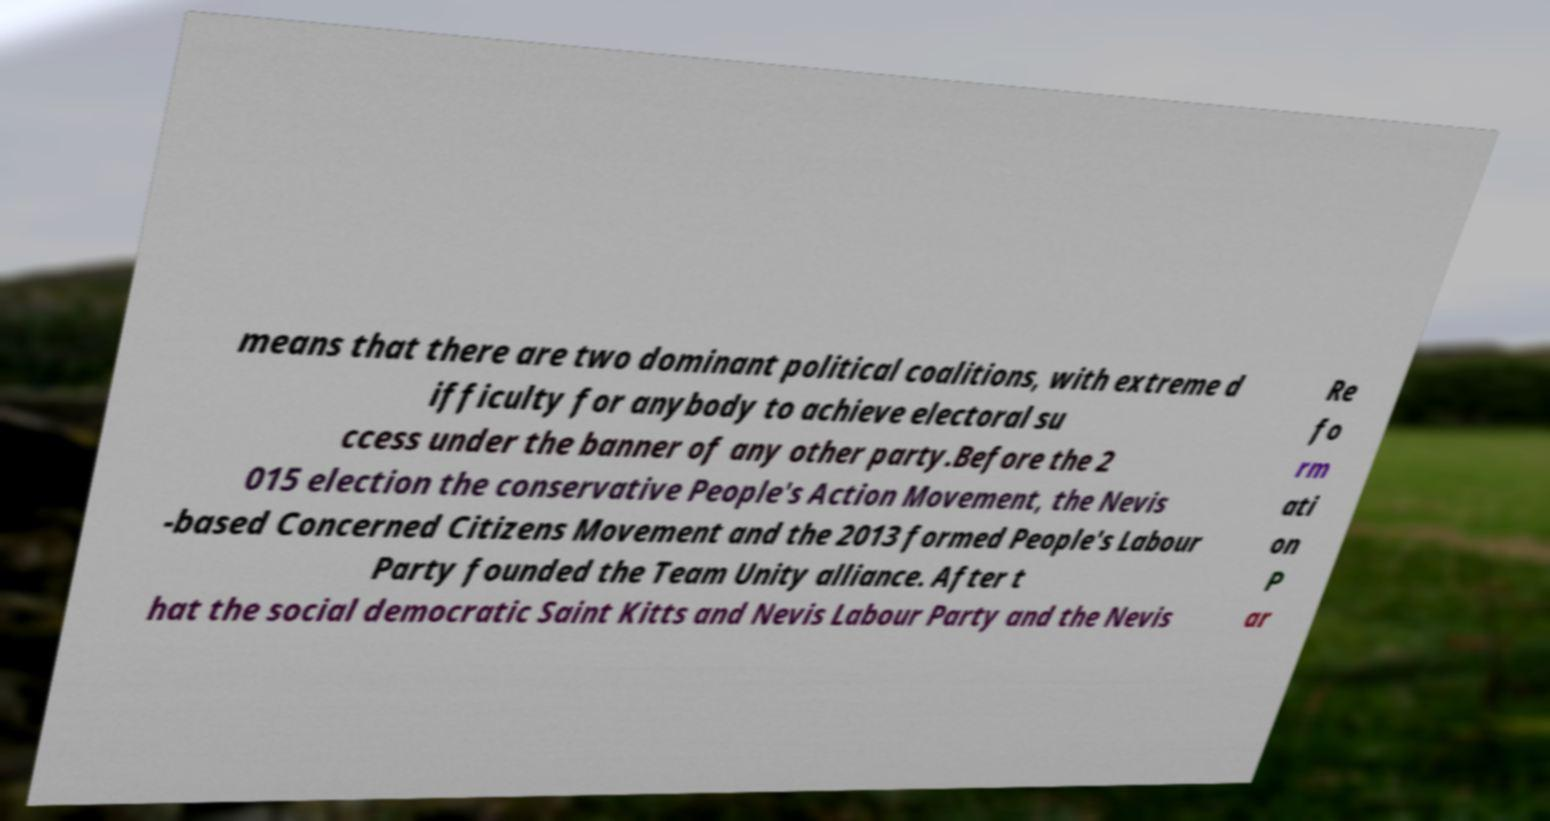There's text embedded in this image that I need extracted. Can you transcribe it verbatim? means that there are two dominant political coalitions, with extreme d ifficulty for anybody to achieve electoral su ccess under the banner of any other party.Before the 2 015 election the conservative People's Action Movement, the Nevis -based Concerned Citizens Movement and the 2013 formed People's Labour Party founded the Team Unity alliance. After t hat the social democratic Saint Kitts and Nevis Labour Party and the Nevis Re fo rm ati on P ar 